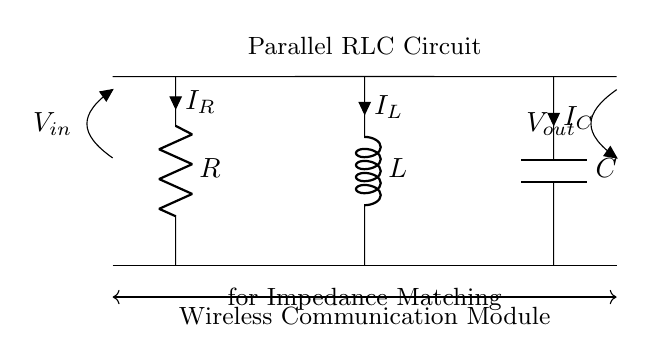What components are present in this circuit? The circuit includes a resistor, inductor, and capacitor, as indicated by the labeled components (R, L, C).
Answer: Resistor, Inductor, Capacitor What does the label V in represent? The label V in indicates the input voltage applied to the circuit, positioned at the left side where the voltage is marked.
Answer: Input voltage What is the current flowing through the capacitor? The current flowing through the capacitor is denoted as I C in the circuit diagram, shown alongside the capacitor symbol.
Answer: I C Which type of circuit is depicted in this diagram? This is a parallel RLC circuit, as evidenced by the configuration of the resistor, inductor, and capacitor all connected in parallel to each other.
Answer: Parallel RLC circuit How does impedance matching affect this circuit? Impedance matching is crucial for ensuring maximum power transfer between the circuit and the wireless communication module, achieved by adjusting resistance, inductance, and capacitance to minimize reflections.
Answer: Ensures maximum power transfer What is the overall function of the circuit? The overall function of this parallel RLC circuit is to match the impedance of a wireless communication module for optimal performance and power efficiency.
Answer: Impedance matching for wireless communication How does the arrangement of components in this circuit differ from a series circuit? In a parallel arrangement like this, all components share the same voltage across them, unlike in a series circuit where the voltage is divided among components.
Answer: Components share the same voltage 